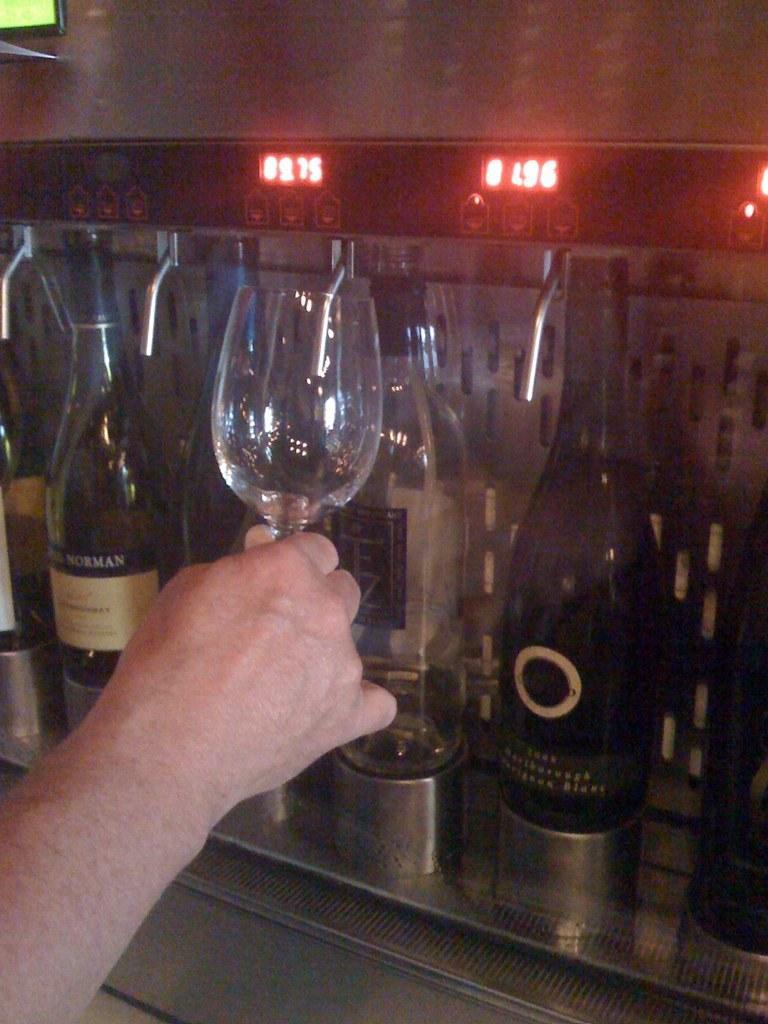How would you summarize this image in a sentence or two? In this picture we can see a person holding a glass. And these are the bottles. 